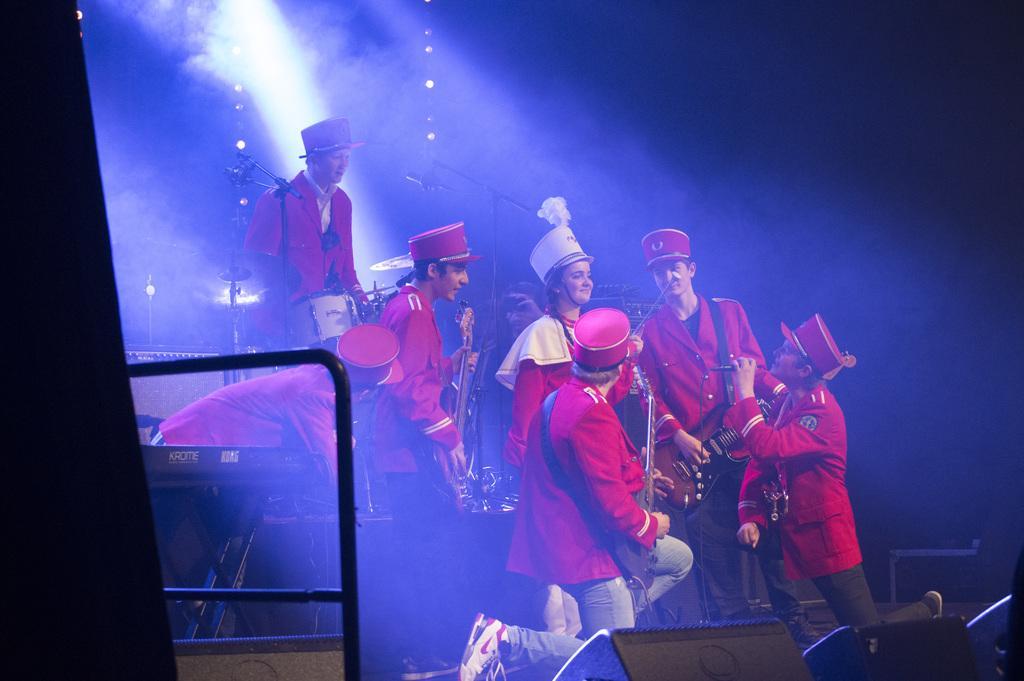Can you describe this image briefly? In this picture we can see a group of people wore caps and playing musical instruments such as guitars and drums and in the background we can see lights and it is dark. 